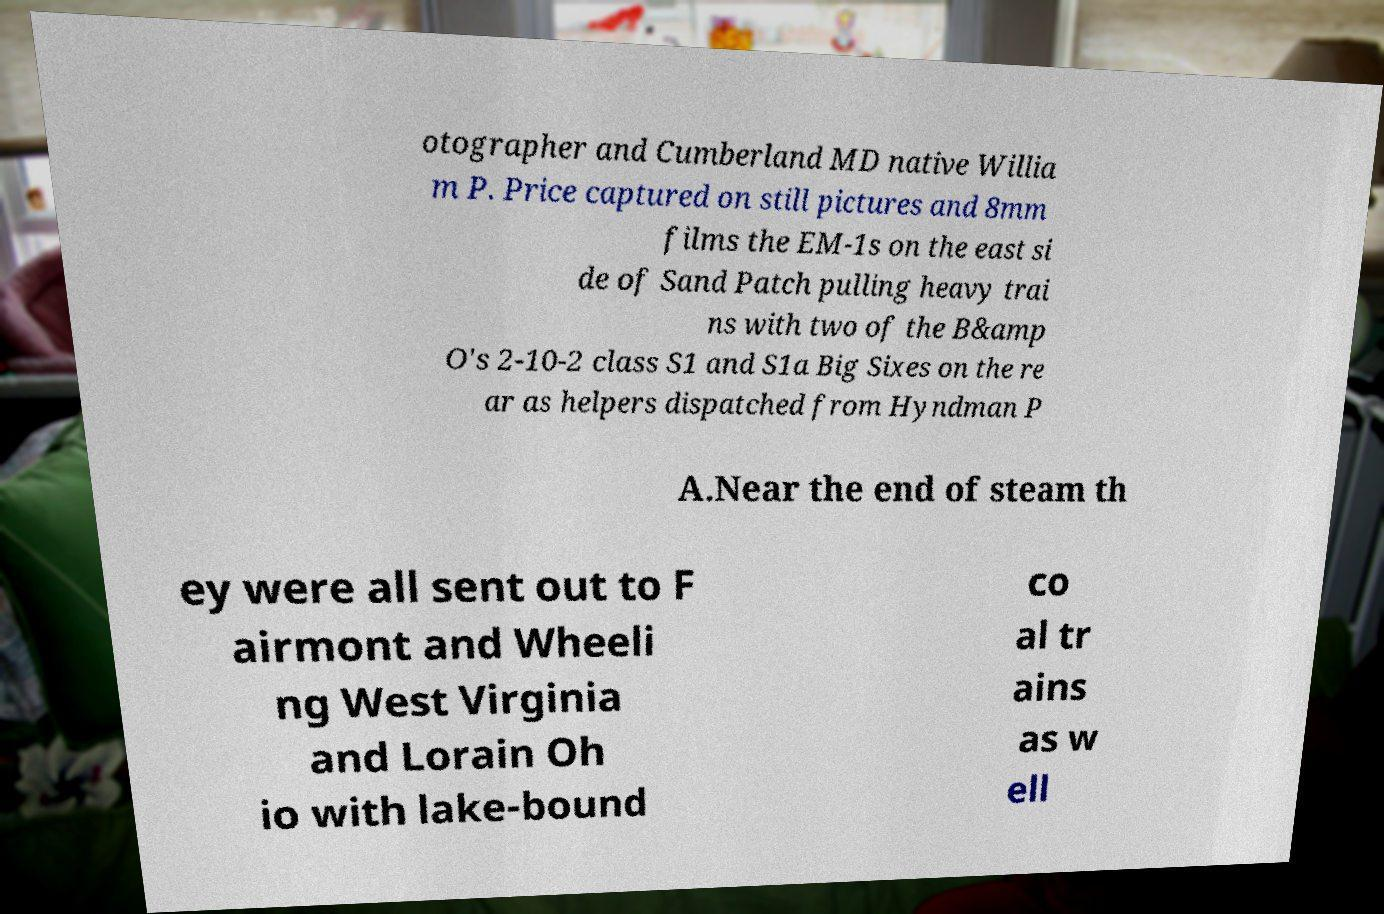Please identify and transcribe the text found in this image. otographer and Cumberland MD native Willia m P. Price captured on still pictures and 8mm films the EM-1s on the east si de of Sand Patch pulling heavy trai ns with two of the B&amp O's 2-10-2 class S1 and S1a Big Sixes on the re ar as helpers dispatched from Hyndman P A.Near the end of steam th ey were all sent out to F airmont and Wheeli ng West Virginia and Lorain Oh io with lake-bound co al tr ains as w ell 